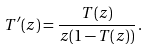<formula> <loc_0><loc_0><loc_500><loc_500>T ^ { \prime } ( z ) = \frac { T ( z ) } { z ( 1 - T ( z ) ) } \, .</formula> 